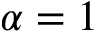<formula> <loc_0><loc_0><loc_500><loc_500>\alpha = 1</formula> 